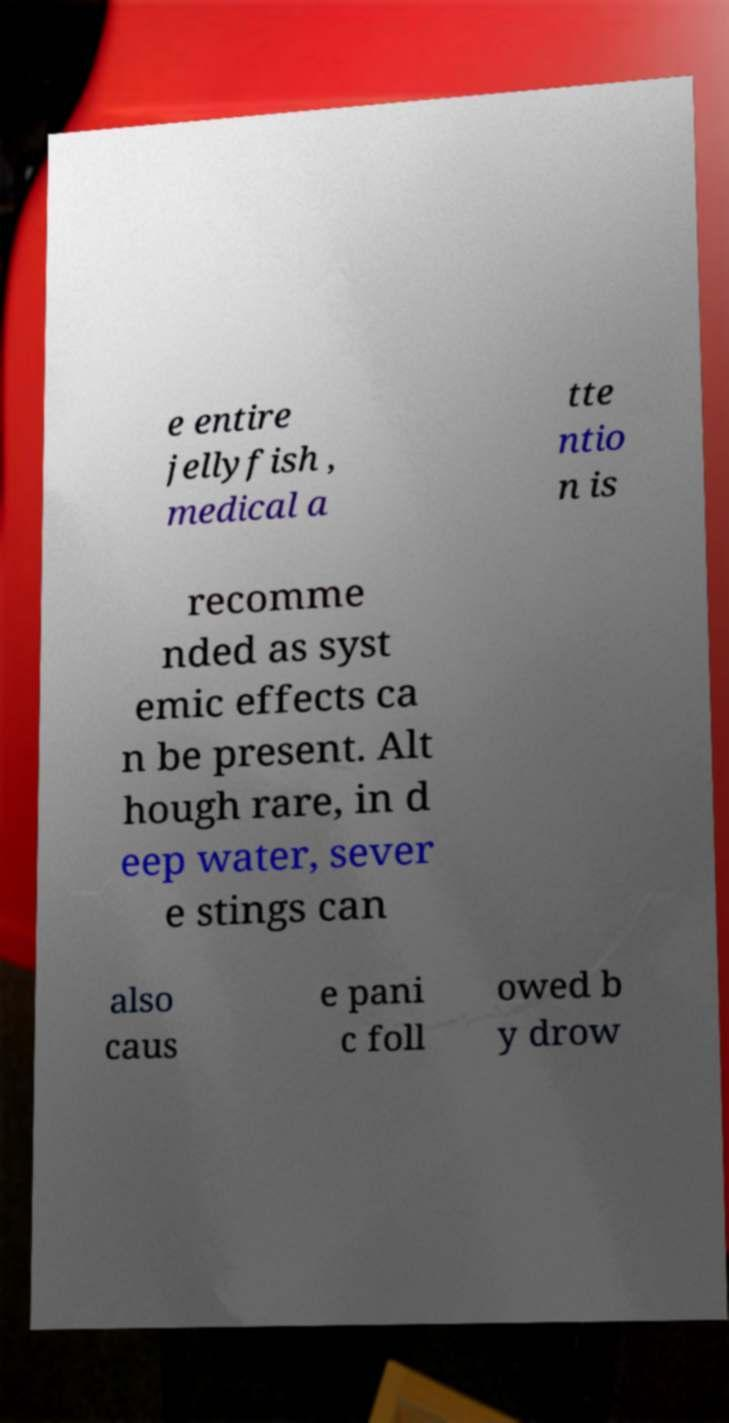For documentation purposes, I need the text within this image transcribed. Could you provide that? e entire jellyfish , medical a tte ntio n is recomme nded as syst emic effects ca n be present. Alt hough rare, in d eep water, sever e stings can also caus e pani c foll owed b y drow 